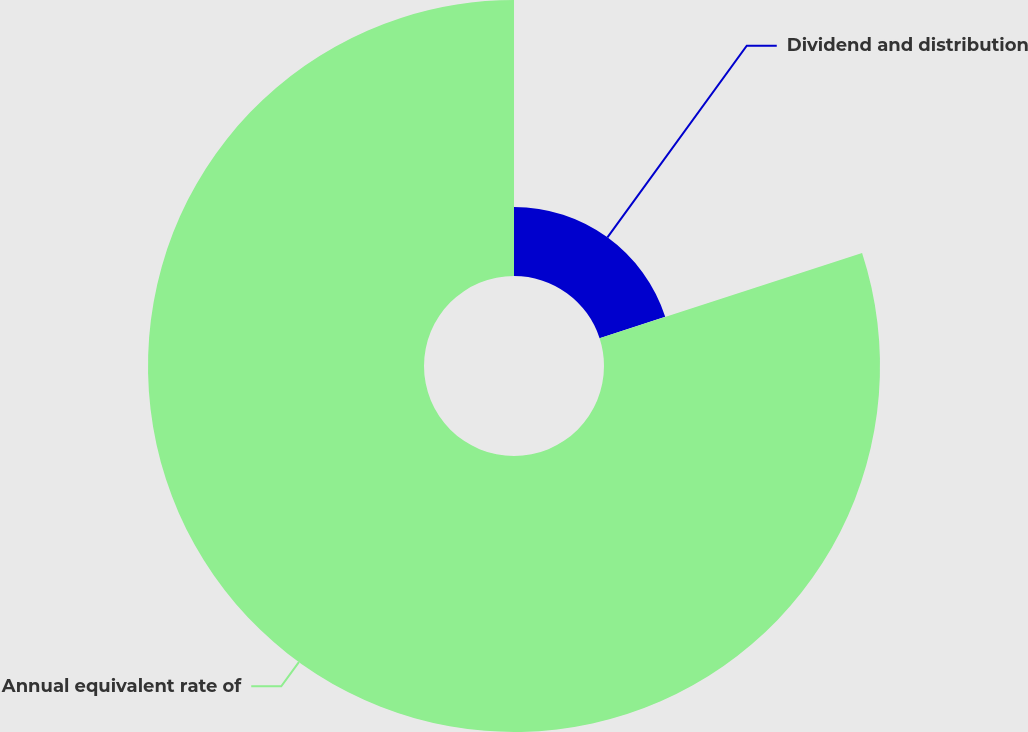Convert chart. <chart><loc_0><loc_0><loc_500><loc_500><pie_chart><fcel>Dividend and distribution<fcel>Annual equivalent rate of<nl><fcel>20.0%<fcel>80.0%<nl></chart> 